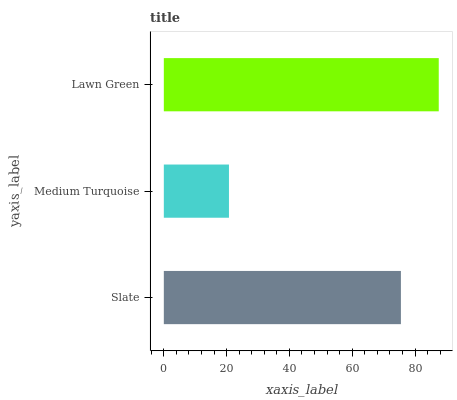Is Medium Turquoise the minimum?
Answer yes or no. Yes. Is Lawn Green the maximum?
Answer yes or no. Yes. Is Lawn Green the minimum?
Answer yes or no. No. Is Medium Turquoise the maximum?
Answer yes or no. No. Is Lawn Green greater than Medium Turquoise?
Answer yes or no. Yes. Is Medium Turquoise less than Lawn Green?
Answer yes or no. Yes. Is Medium Turquoise greater than Lawn Green?
Answer yes or no. No. Is Lawn Green less than Medium Turquoise?
Answer yes or no. No. Is Slate the high median?
Answer yes or no. Yes. Is Slate the low median?
Answer yes or no. Yes. Is Medium Turquoise the high median?
Answer yes or no. No. Is Medium Turquoise the low median?
Answer yes or no. No. 